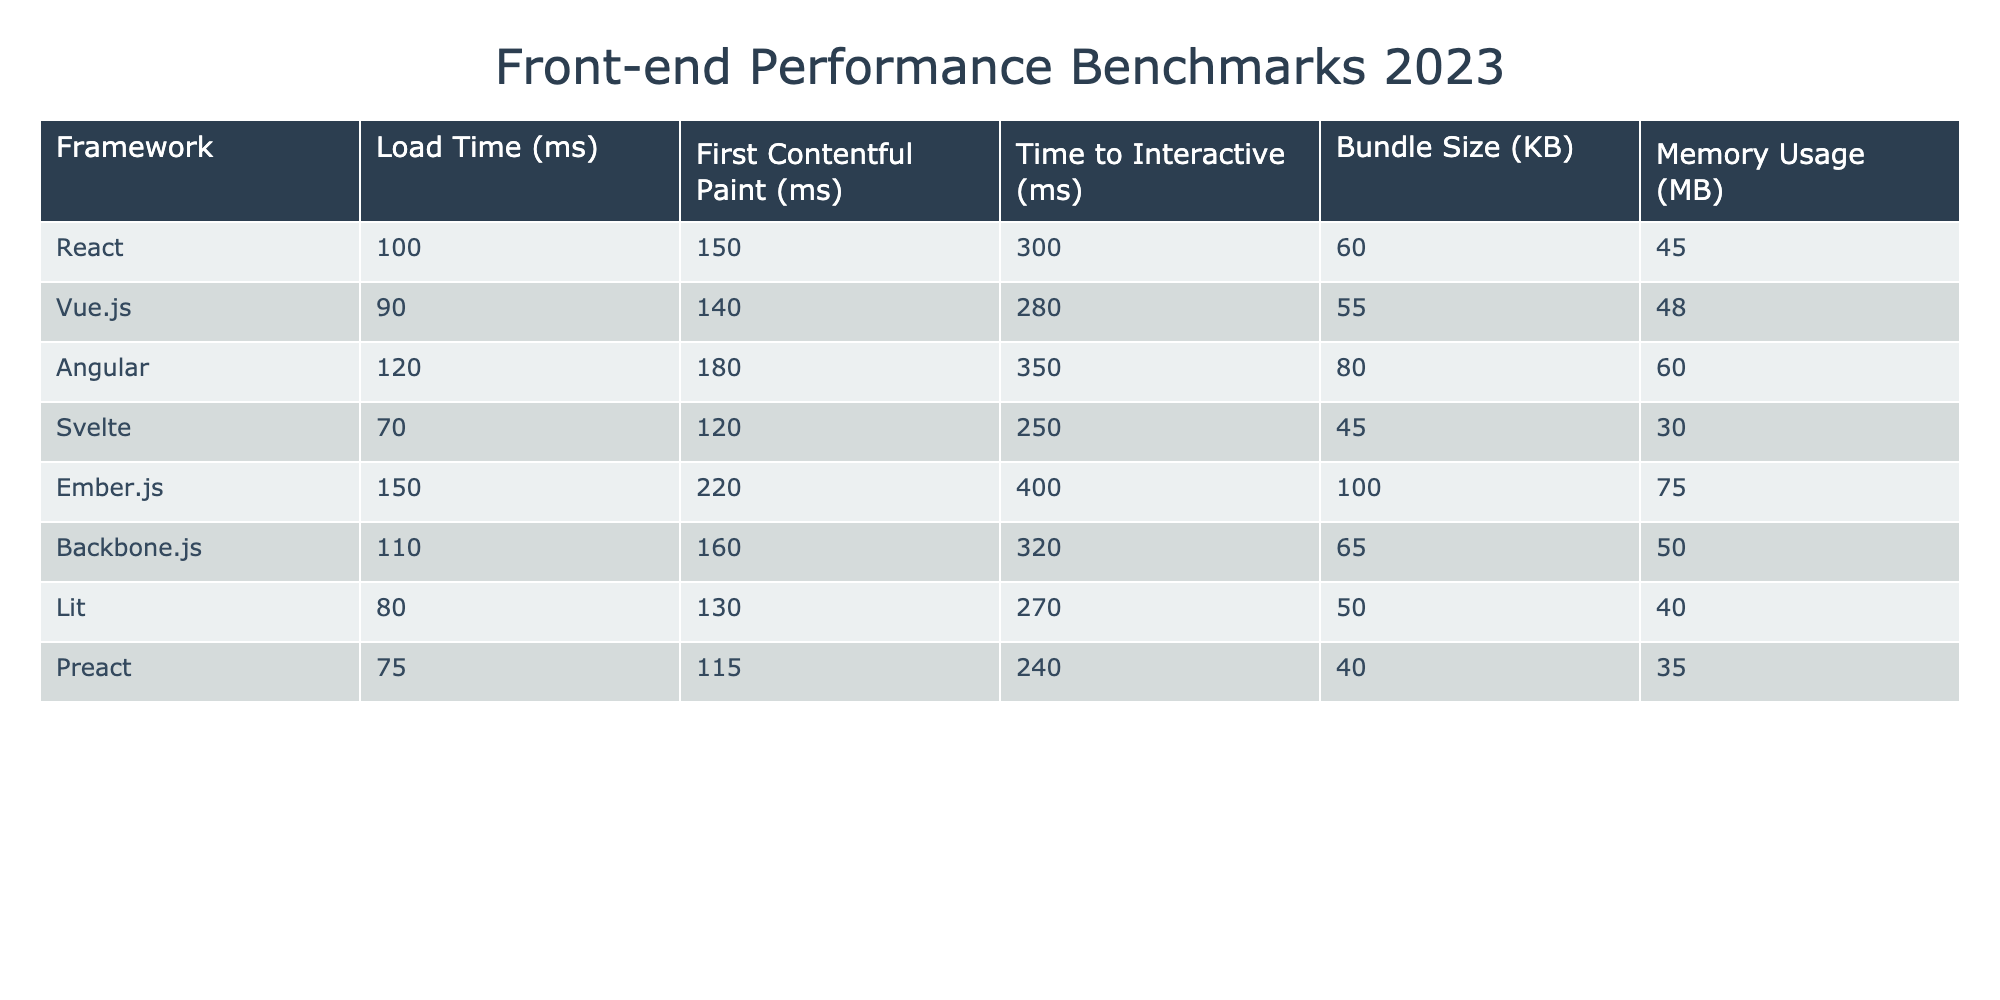What is the load time for Svelte? The table shows that the load time for Svelte is 70 ms, as listed under the "Load Time (ms)" column for the Svelte row.
Answer: 70 ms Which framework has the highest first contentful paint time? By examining the "First Contentful Paint (ms)" column, I can see that Ember.js has the highest value at 220 ms.
Answer: Ember.js What is the average time to interactive for all frameworks? To find the average time to interactive, I add all the "Time to Interactive (ms)" values: (300 + 280 + 350 + 250 + 400 + 320 + 270 + 240) = 2410. Then I divide by the number of frameworks, which is 8. The average is 2410 / 8 = 301.25 ms.
Answer: 301.25 ms Does React have a smaller bundle size than Vue.js? Looking at the "Bundle Size (KB)" column, I see that React's bundle size is 60 KB and Vue.js's bundle size is 55 KB. Since 60 is greater than 55, the statement is false.
Answer: No What is the difference in memory usage between Angular and Svelte? The memory usage for Angular is 60 MB and for Svelte it is 30 MB. To find the difference, I subtract Svelte's memory usage from Angular's: 60 - 30 = 30 MB.
Answer: 30 MB Which framework has the lowest load time and what is that value? By examining the "Load Time (ms)" column, Svelte has the lowest load time at 70 ms, as it shows the smallest number compared to other frameworks.
Answer: 70 ms Is the time to interactive for Backbone.js higher than the time to interactive for Preact? The time to interactive for Backbone.js is 320 ms and for Preact is 240 ms. Since 320 is greater than 240, the statement is true.
Answer: Yes What is the total bundle size of the top three frameworks based on load time? The top three frameworks based on load time are Svelte (45 KB), Preact (40 KB), and Vue.js (55 KB). Adding their bundle sizes gives (45 + 40 + 55) = 140 KB.
Answer: 140 KB Which framework has the second highest memory usage and what is that usage? The memory usage values are: React (45 MB), Vue.js (48 MB), Angular (60 MB), Svelte (30 MB), Ember.js (75 MB), Backbone.js (50 MB), Lit (40 MB), and Preact (35 MB). Sorting these, Ember.js has the highest (75 MB) and Angular the second highest at 60 MB.
Answer: Angular, 60 MB 